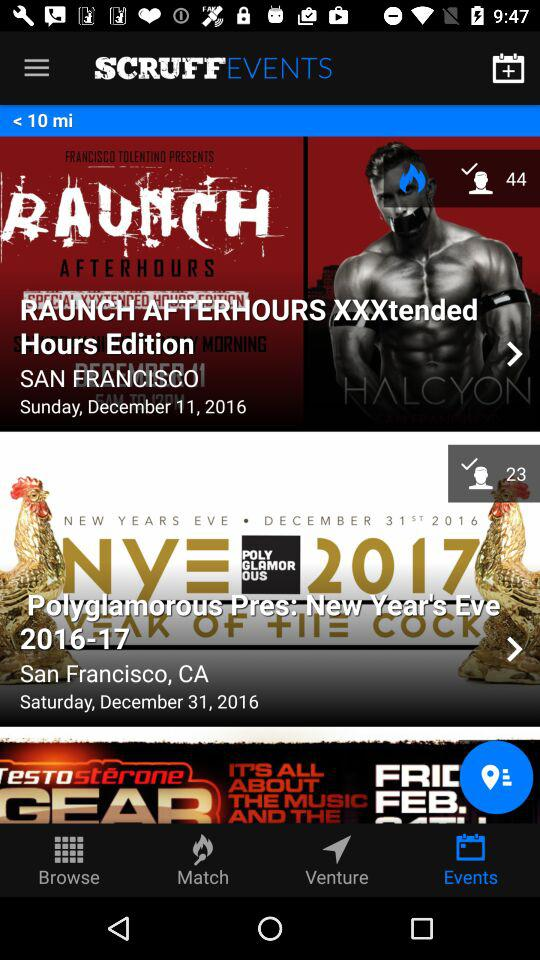What is the day on December 11, 2016? The day is Sunday. 